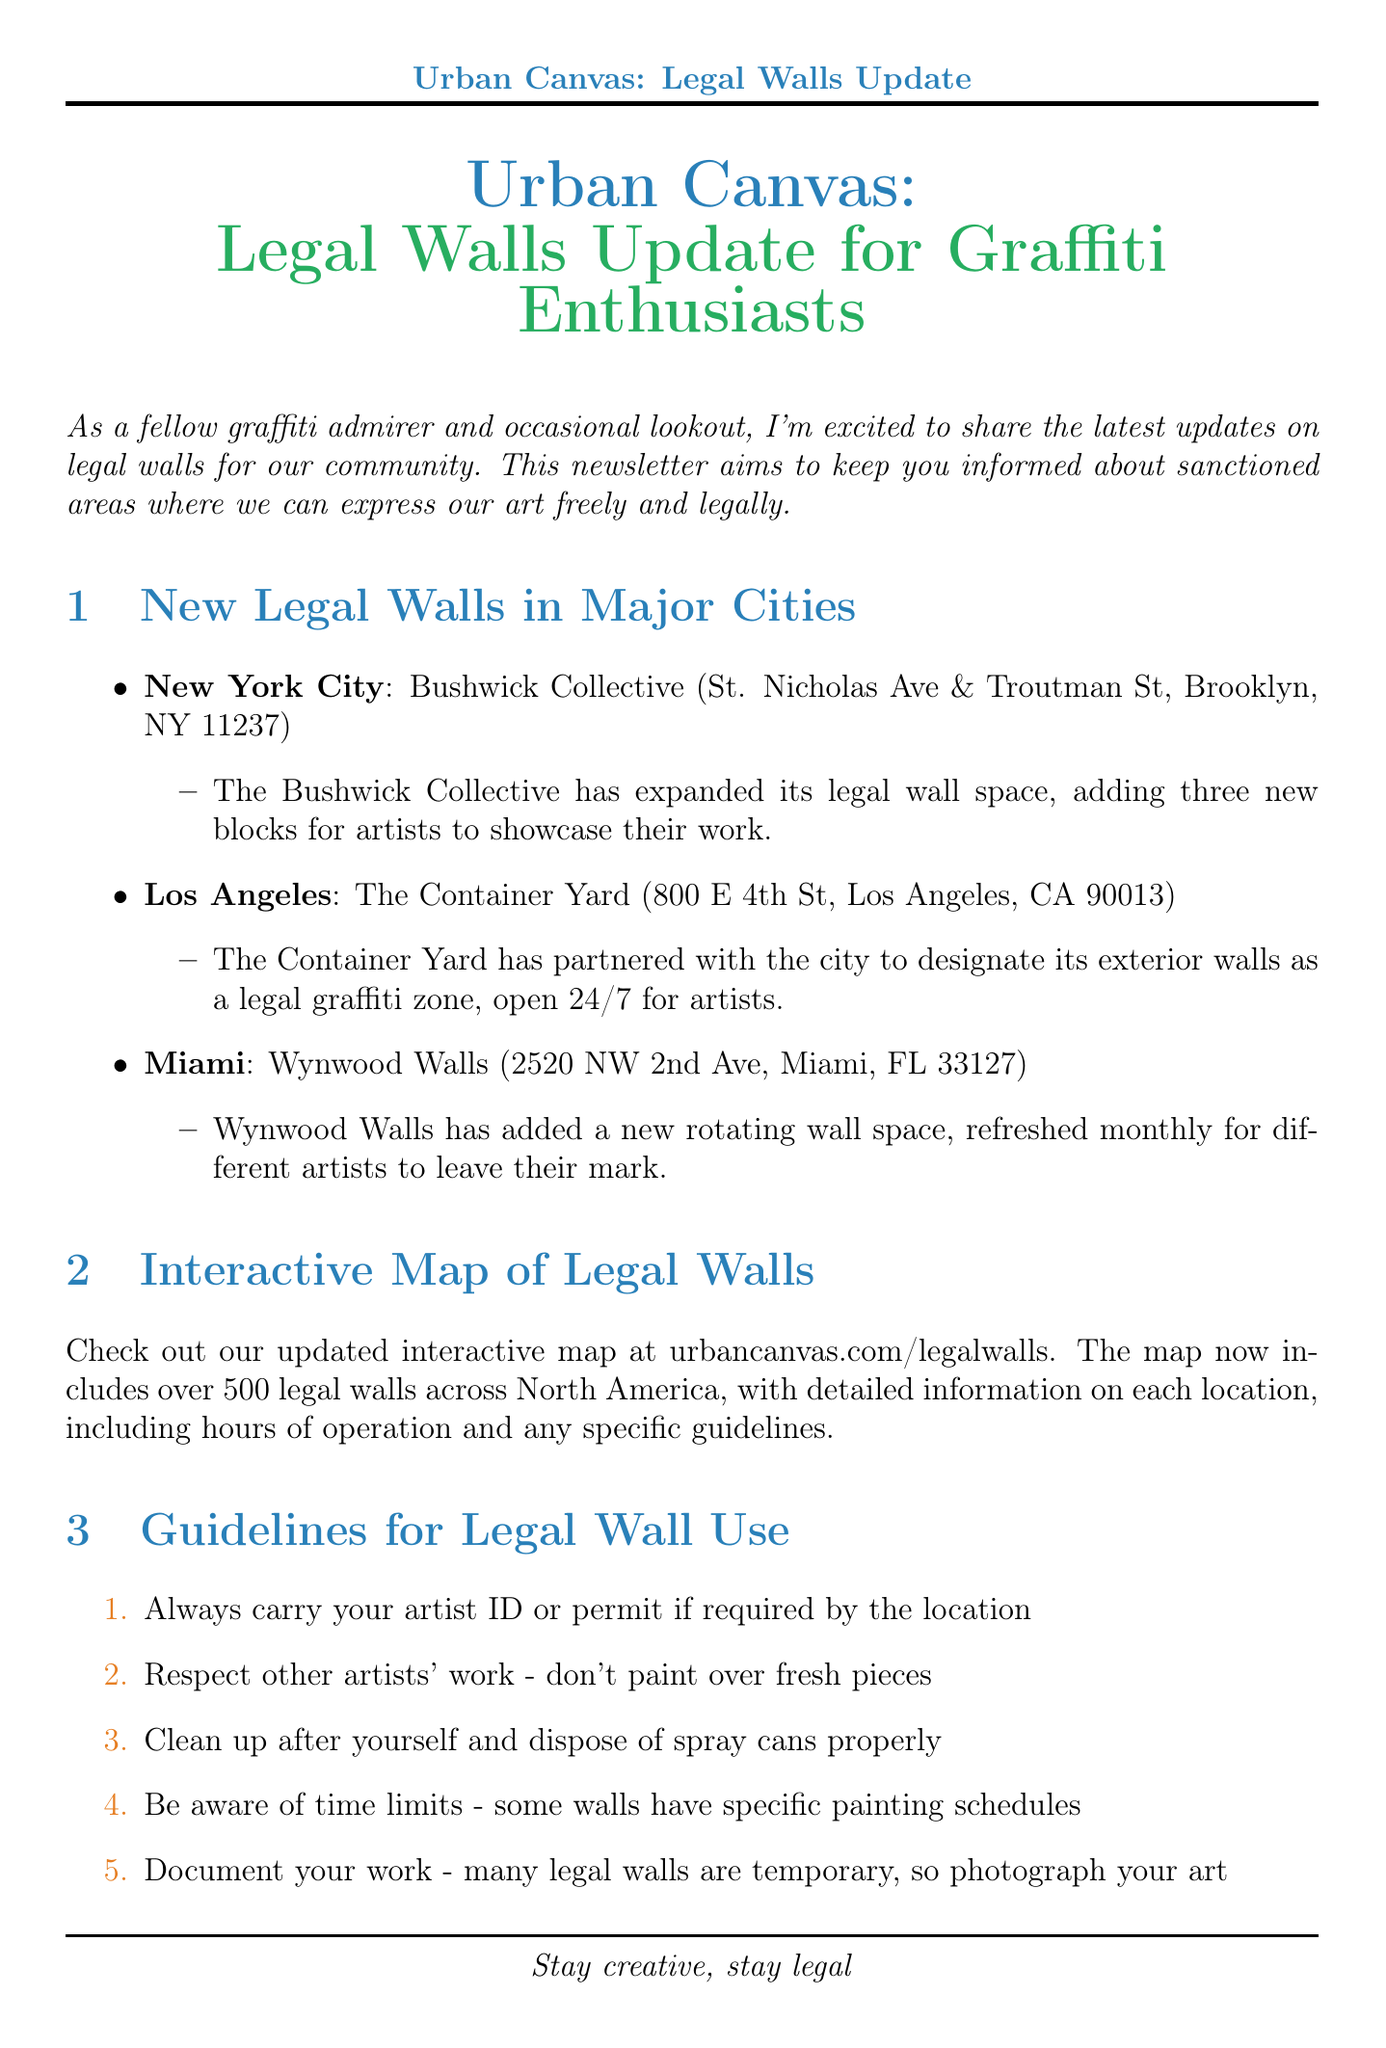What city is the Bushwick Collective located in? The document states that the Bushwick Collective is located in New York City.
Answer: New York City How many new blocks have been added at the Bushwick Collective? The document mentions that three new blocks have been added for artists.
Answer: Three What is the address of Wynwood Walls? The document provides the address as 2520 NW 2nd Ave, Miami, FL 33127.
Answer: 2520 NW 2nd Ave, Miami, FL 33127 What percentage of the document discusses guidelines for legal wall use? The guidelines section includes a list of five points within the newsletter, showcasing significant content about legal wall usage.
Answer: Approximately 11% What is the purpose of the interactive map mentioned in the document? The map is aimed at providing detailed information on over 500 legal walls, including location specifics, hours, and guidelines.
Answer: To inform about legal walls When does the Crush Walls event take place? The document specifies that the Crush Walls event will occur from September 2-8, 2023.
Answer: September 2-8, 2023 What is a common communication method suggested for lookouts? The document recommends using hand signals or messaging apps for discreet communication.
Answer: Hand signals or messaging apps What is the main theme of the newsletter? The newsletter focuses on providing updates about legal walls for graffiti enthusiasts and artists to create legally.
Answer: Legal walls for graffiti enthusiasts 